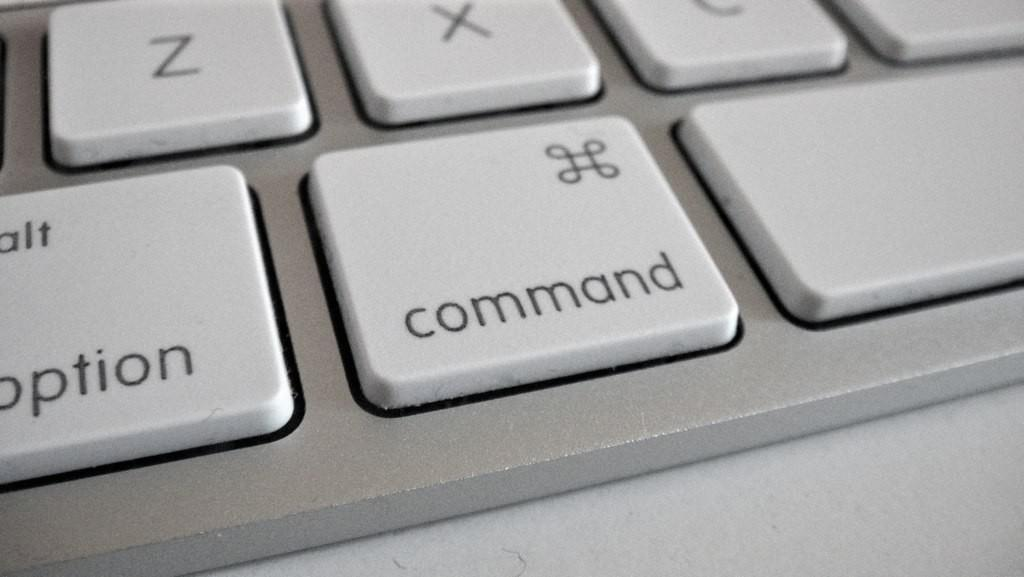<image>
Write a terse but informative summary of the picture. A white keyboard shows the command button next to the option button 